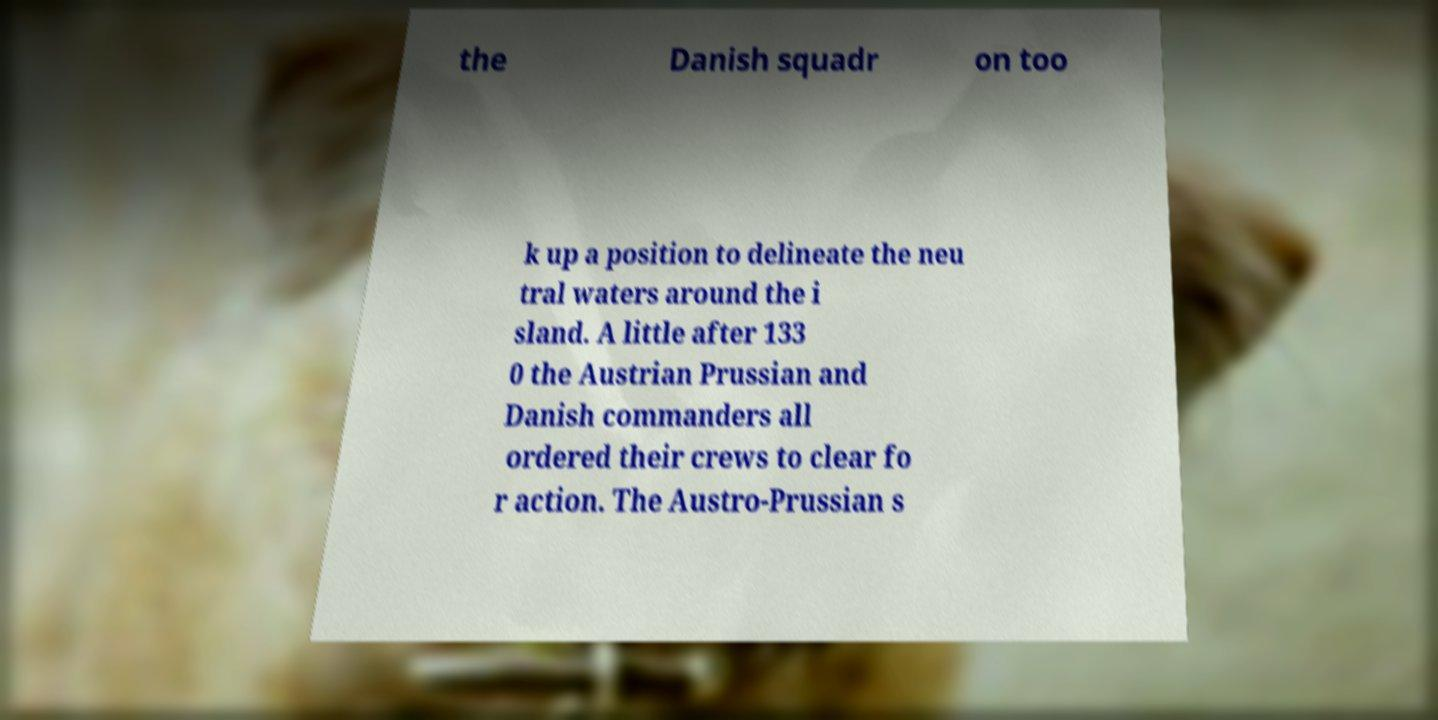What messages or text are displayed in this image? I need them in a readable, typed format. the Danish squadr on too k up a position to delineate the neu tral waters around the i sland. A little after 133 0 the Austrian Prussian and Danish commanders all ordered their crews to clear fo r action. The Austro-Prussian s 